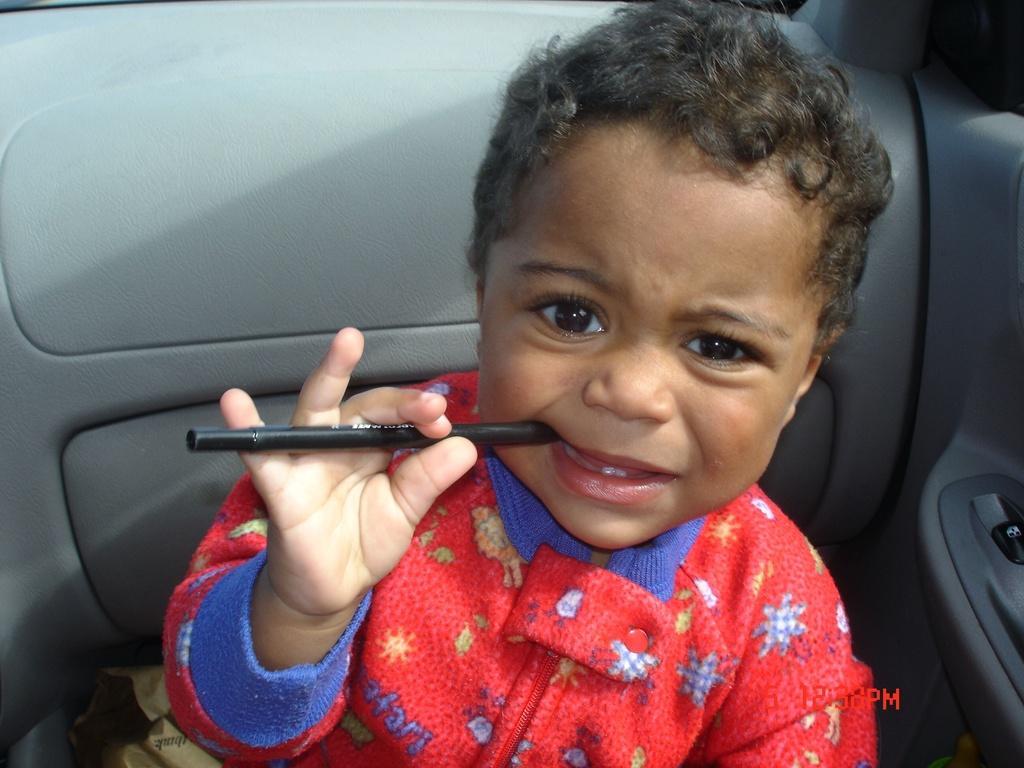How would you summarize this image in a sentence or two? In the image a boy is holding a pen and sitting in a vehicle. 